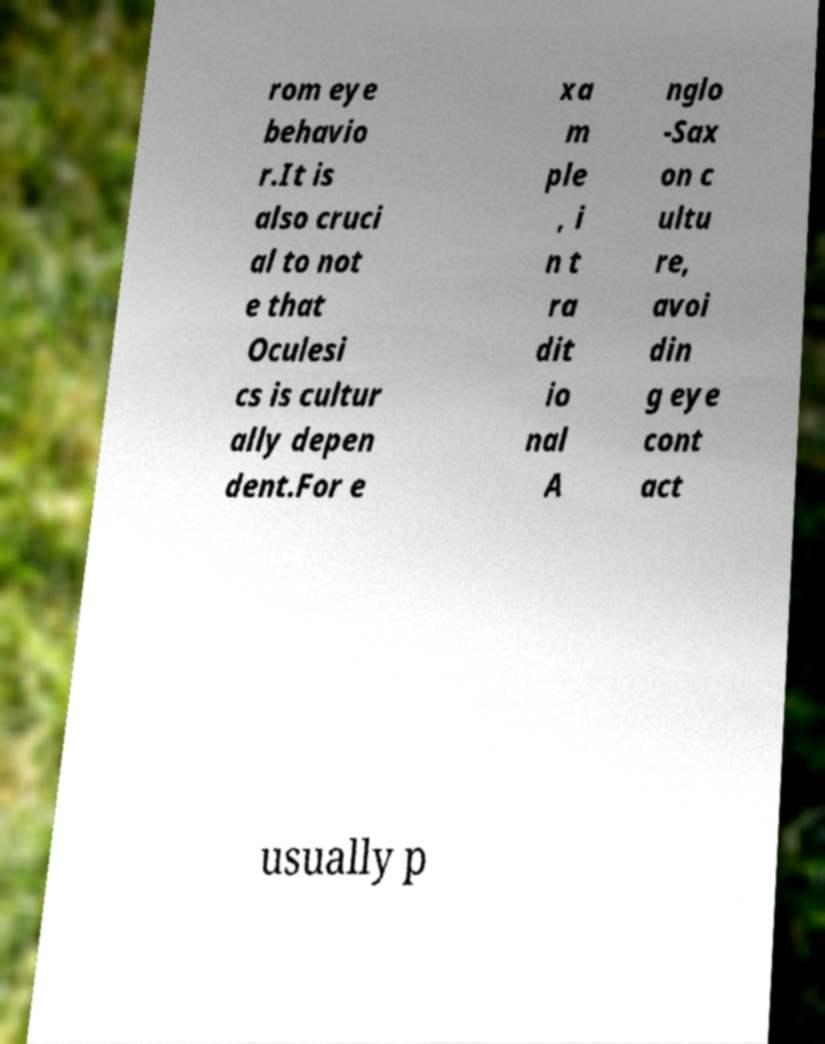Could you assist in decoding the text presented in this image and type it out clearly? rom eye behavio r.It is also cruci al to not e that Oculesi cs is cultur ally depen dent.For e xa m ple , i n t ra dit io nal A nglo -Sax on c ultu re, avoi din g eye cont act usually p 